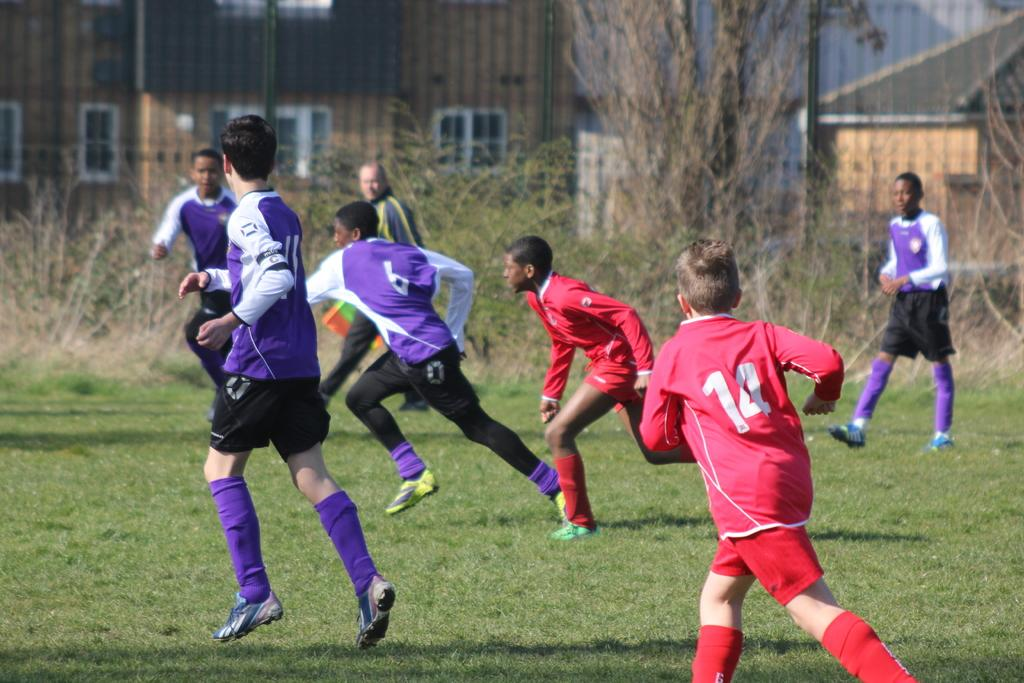What are the boys in the image doing? The boys in the image are running on the ground. What is the man in the image doing? The man in the image is walking. What type of vegetation can be seen in the image? Grass and trees are visible in the image. What can be seen in the background of the image? There are buildings with windows in the background. What type of wealth can be seen in the image? There is no indication of wealth in the image; it features boys running, a man walking, grass, trees, and buildings with windows. Can you tell me how many boats are present in the image? There are no boats present in the image. 